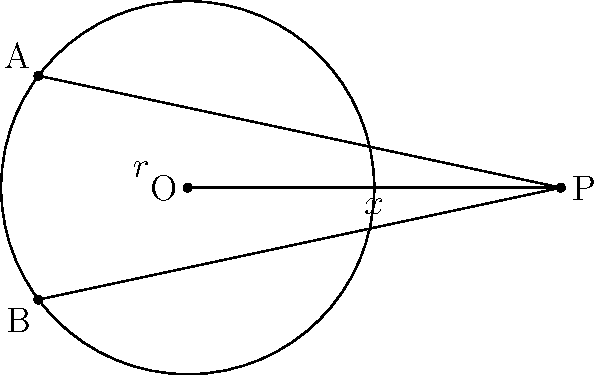In the film adaptation of "Tangent Lines," a crucial scene takes place in a circular amphitheater. The director, inspired by the book's geometric descriptions, sets up a shot where a character stands at point P, outside the amphitheater. Two tangent lines are drawn from P to the circle, touching at points A and B. If the radius of the amphitheater is $r$ and the distance from the center O to point P is $x$, prove that $PA^2 = x^2 - r^2$. Let's approach this proof step-by-step:

1) In the right triangle OPA:
   $$OA^2 + PA^2 = OP^2$$ (by the Pythagorean theorem)

2) We know that OA is a radius of the circle, so $OA = r$
   $$r^2 + PA^2 = x^2$$

3) Rearranging the equation:
   $$PA^2 = x^2 - r^2$$

4) This proves the statement.

As a film critic and fan of the book, you might appreciate how this geometric property could be used symbolically in the story. The distance $PA$ represents the character's connection to the amphitheater (the circle), which is influenced by their distance from the center ($x$) and the size of the amphitheater itself ($r$).
Answer: $PA^2 = x^2 - r^2$ 